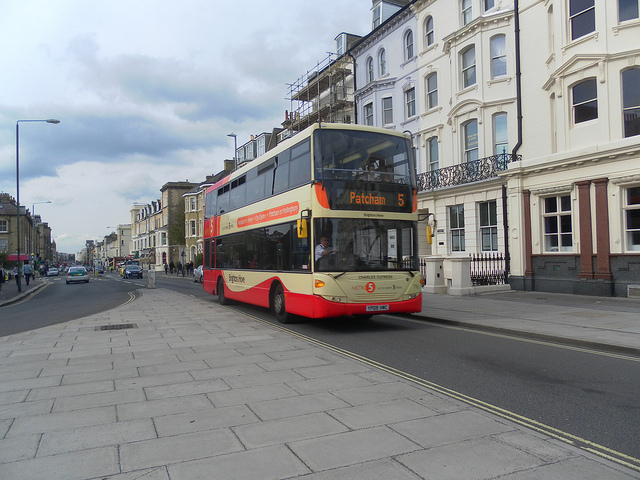Extract all visible text content from this image. Patcham 5 5 